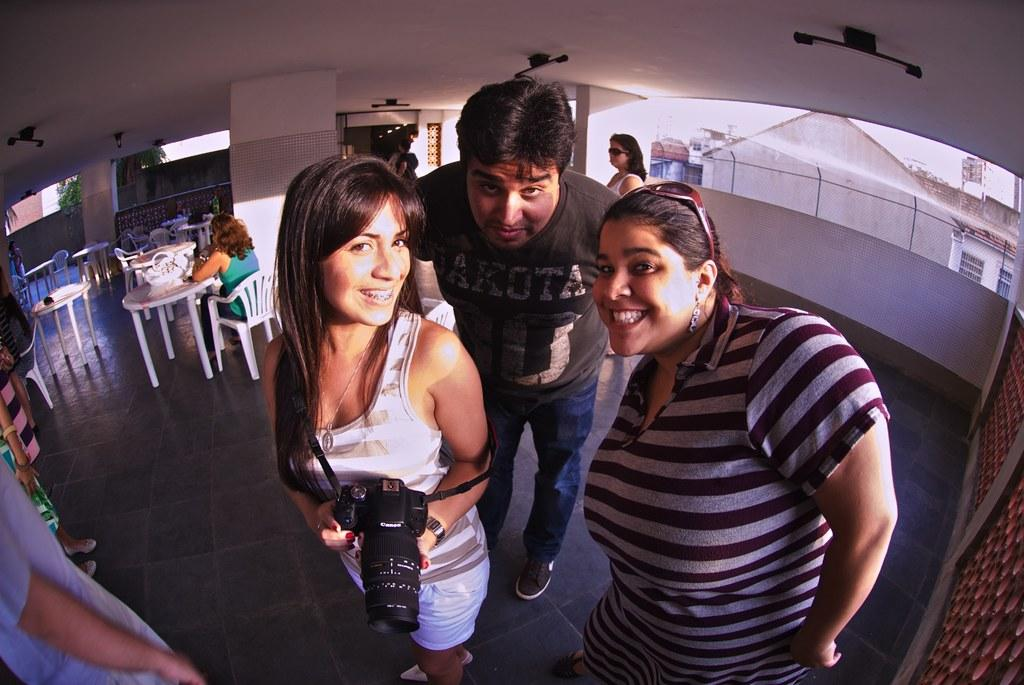How many people are present in the image? There are three people in the image: one man and two women. What are the expressions on their faces? The man and women are smiling in the image. What might the woman holding the camera be doing? The woman holding the camera might be taking a picture or capturing a moment. What type of furniture is visible in the image? Tables and chairs are visible in the image. What type of riddle can be seen on the table in the image? There is no riddle visible on the table in the image. Can you tell me how the sail is being used in the image? There is no sail present in the image. 